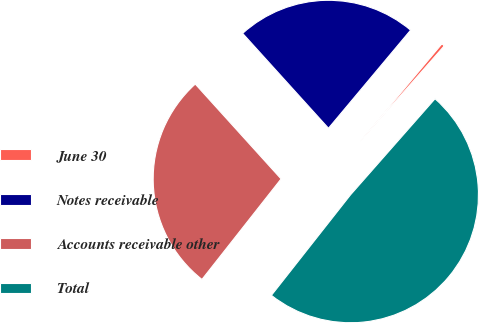<chart> <loc_0><loc_0><loc_500><loc_500><pie_chart><fcel>June 30<fcel>Notes receivable<fcel>Accounts receivable other<fcel>Total<nl><fcel>0.39%<fcel>22.8%<fcel>27.68%<fcel>49.13%<nl></chart> 